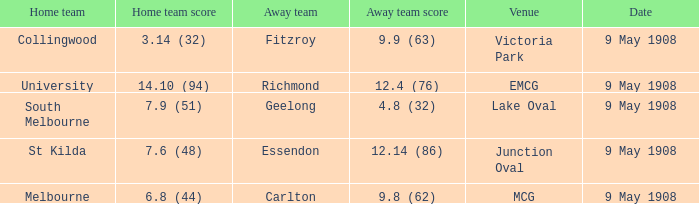At lake oval, what is the score for the team not playing at home? 4.8 (32). 